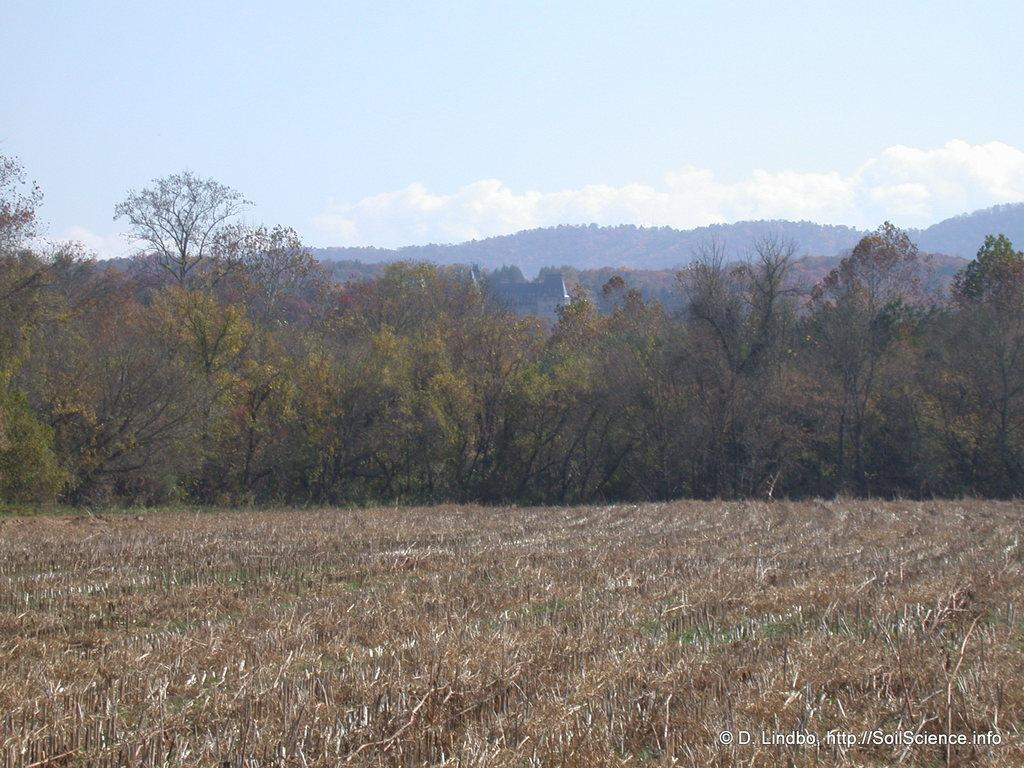What type of natural features can be seen in the image? There are trees and mountains in the image. What is visible in the background of the image? The sky is visible in the background of the image. What can be seen in the sky? Clouds are present in the sky. What type of harmony is being played by the trees in the image? There is no indication of harmony or music in the image; it features trees, mountains, and a sky with clouds. 